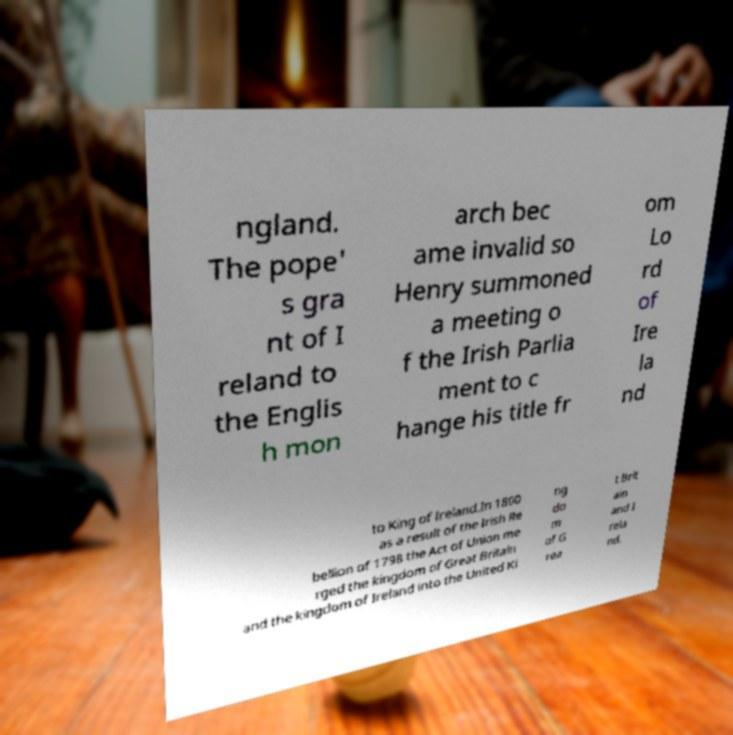I need the written content from this picture converted into text. Can you do that? ngland. The pope' s gra nt of I reland to the Englis h mon arch bec ame invalid so Henry summoned a meeting o f the Irish Parlia ment to c hange his title fr om Lo rd of Ire la nd to King of Ireland.In 1800 as a result of the Irish Re bellion of 1798 the Act of Union me rged the kingdom of Great Britain and the kingdom of Ireland into the United Ki ng do m of G rea t Brit ain and I rela nd. 